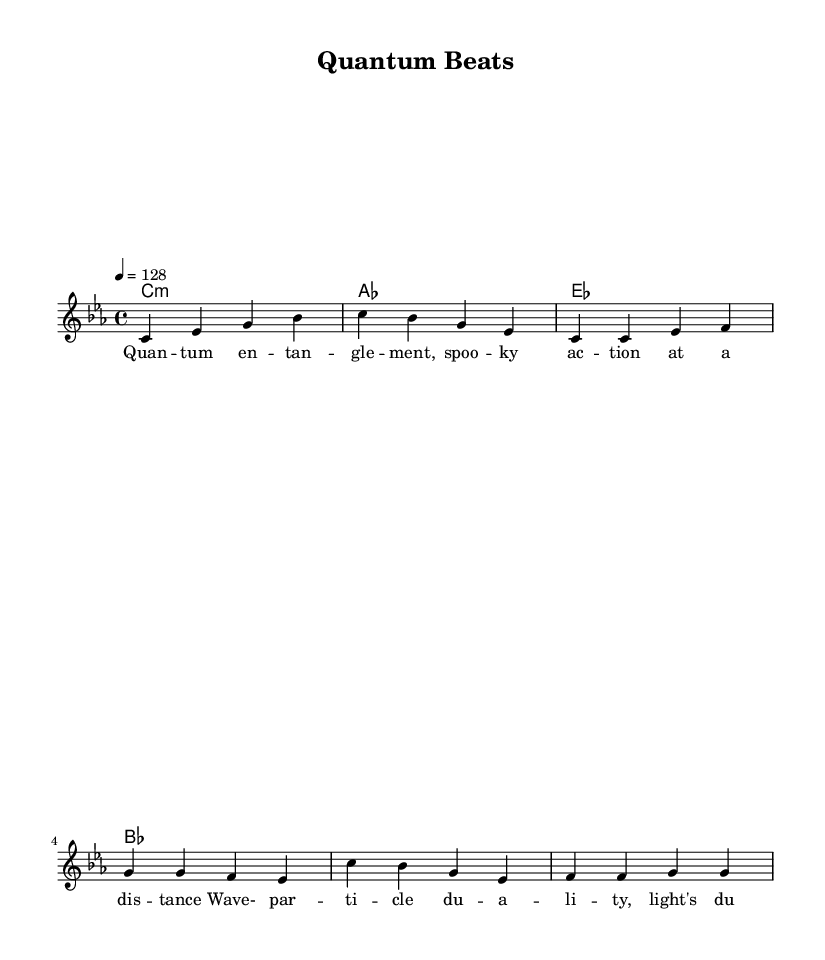What is the key signature of this music? The key signature is indicated by the symbol at the beginning of the staff. Here, it shows 3 flats, which correspond to the key of E-flat minor or C minor.
Answer: C minor What is the time signature of the piece? The time signature is shown as a fraction at the beginning of the staff. In this case, it is 4/4, meaning there are four beats in each measure and the quarter note gets one beat.
Answer: 4/4 What is the tempo marking in the score? The tempo marking is indicated on the score as "4 = 128", meaning there are 128 beats per minute, with each quarter note a beat.
Answer: 128 How many unique chords are used in the harmonies section? The harmonies section lists the chords used in the piece. There are four distinct chords present in the sequence: C minor, A-flat major, E-flat major, and B-flat major.
Answer: 4 What are the first two words of the lyrics? The lyrics section is positioned below the melody. The first two words are 'Quantum entanglement,' which make up the beginning of the lyrics.
Answer: Quantum entanglement How does the chorus differ from the verses in this piece? To determine the difference, we need to analyze structure. The verses are played in the sequence of a specific set of notes, while the chorus features a different sequence different melody, suggesting a distinct thematic evolution.
Answer: Different melody What scientific concept does the title refer to? The title "Quantum Beats" refers to a concept from quantum mechanics, which often concerns wave-particle duality and interactions at a quantum level, implying the influence of science in the music's theme.
Answer: Quantum mechanics 